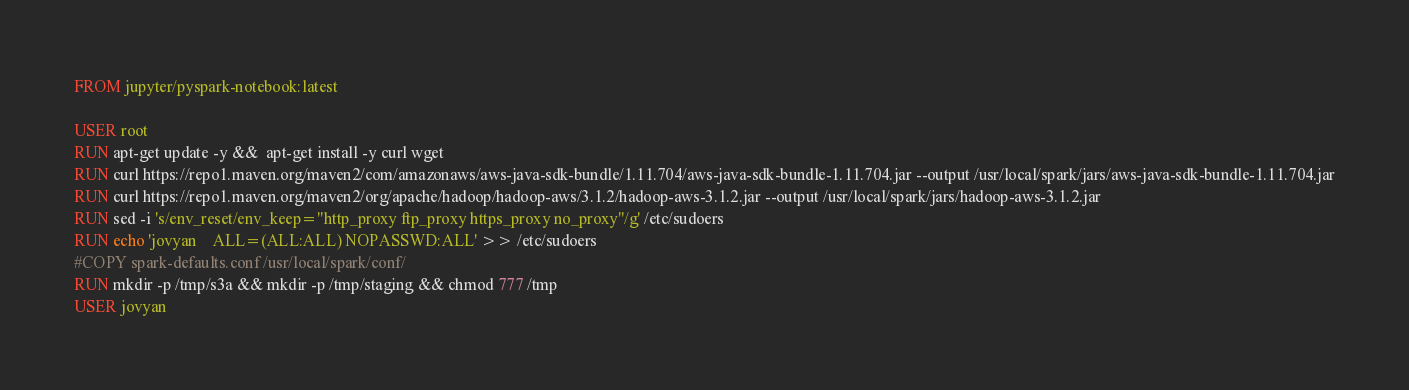<code> <loc_0><loc_0><loc_500><loc_500><_Dockerfile_>FROM jupyter/pyspark-notebook:latest

USER root
RUN apt-get update -y &&  apt-get install -y curl wget
RUN curl https://repo1.maven.org/maven2/com/amazonaws/aws-java-sdk-bundle/1.11.704/aws-java-sdk-bundle-1.11.704.jar --output /usr/local/spark/jars/aws-java-sdk-bundle-1.11.704.jar
RUN curl https://repo1.maven.org/maven2/org/apache/hadoop/hadoop-aws/3.1.2/hadoop-aws-3.1.2.jar --output /usr/local/spark/jars/hadoop-aws-3.1.2.jar
RUN sed -i 's/env_reset/env_keep="http_proxy ftp_proxy https_proxy no_proxy"/g' /etc/sudoers
RUN echo 'jovyan    ALL=(ALL:ALL) NOPASSWD:ALL' >> /etc/sudoers
#COPY spark-defaults.conf /usr/local/spark/conf/
RUN mkdir -p /tmp/s3a && mkdir -p /tmp/staging && chmod 777 /tmp
USER jovyan</code> 